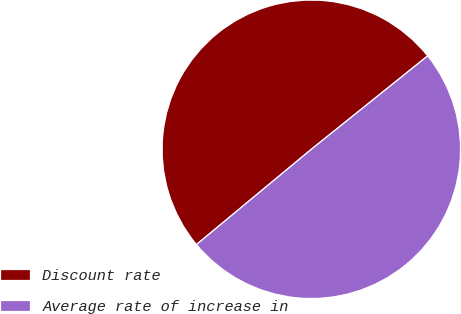Convert chart. <chart><loc_0><loc_0><loc_500><loc_500><pie_chart><fcel>Discount rate<fcel>Average rate of increase in<nl><fcel>50.26%<fcel>49.74%<nl></chart> 